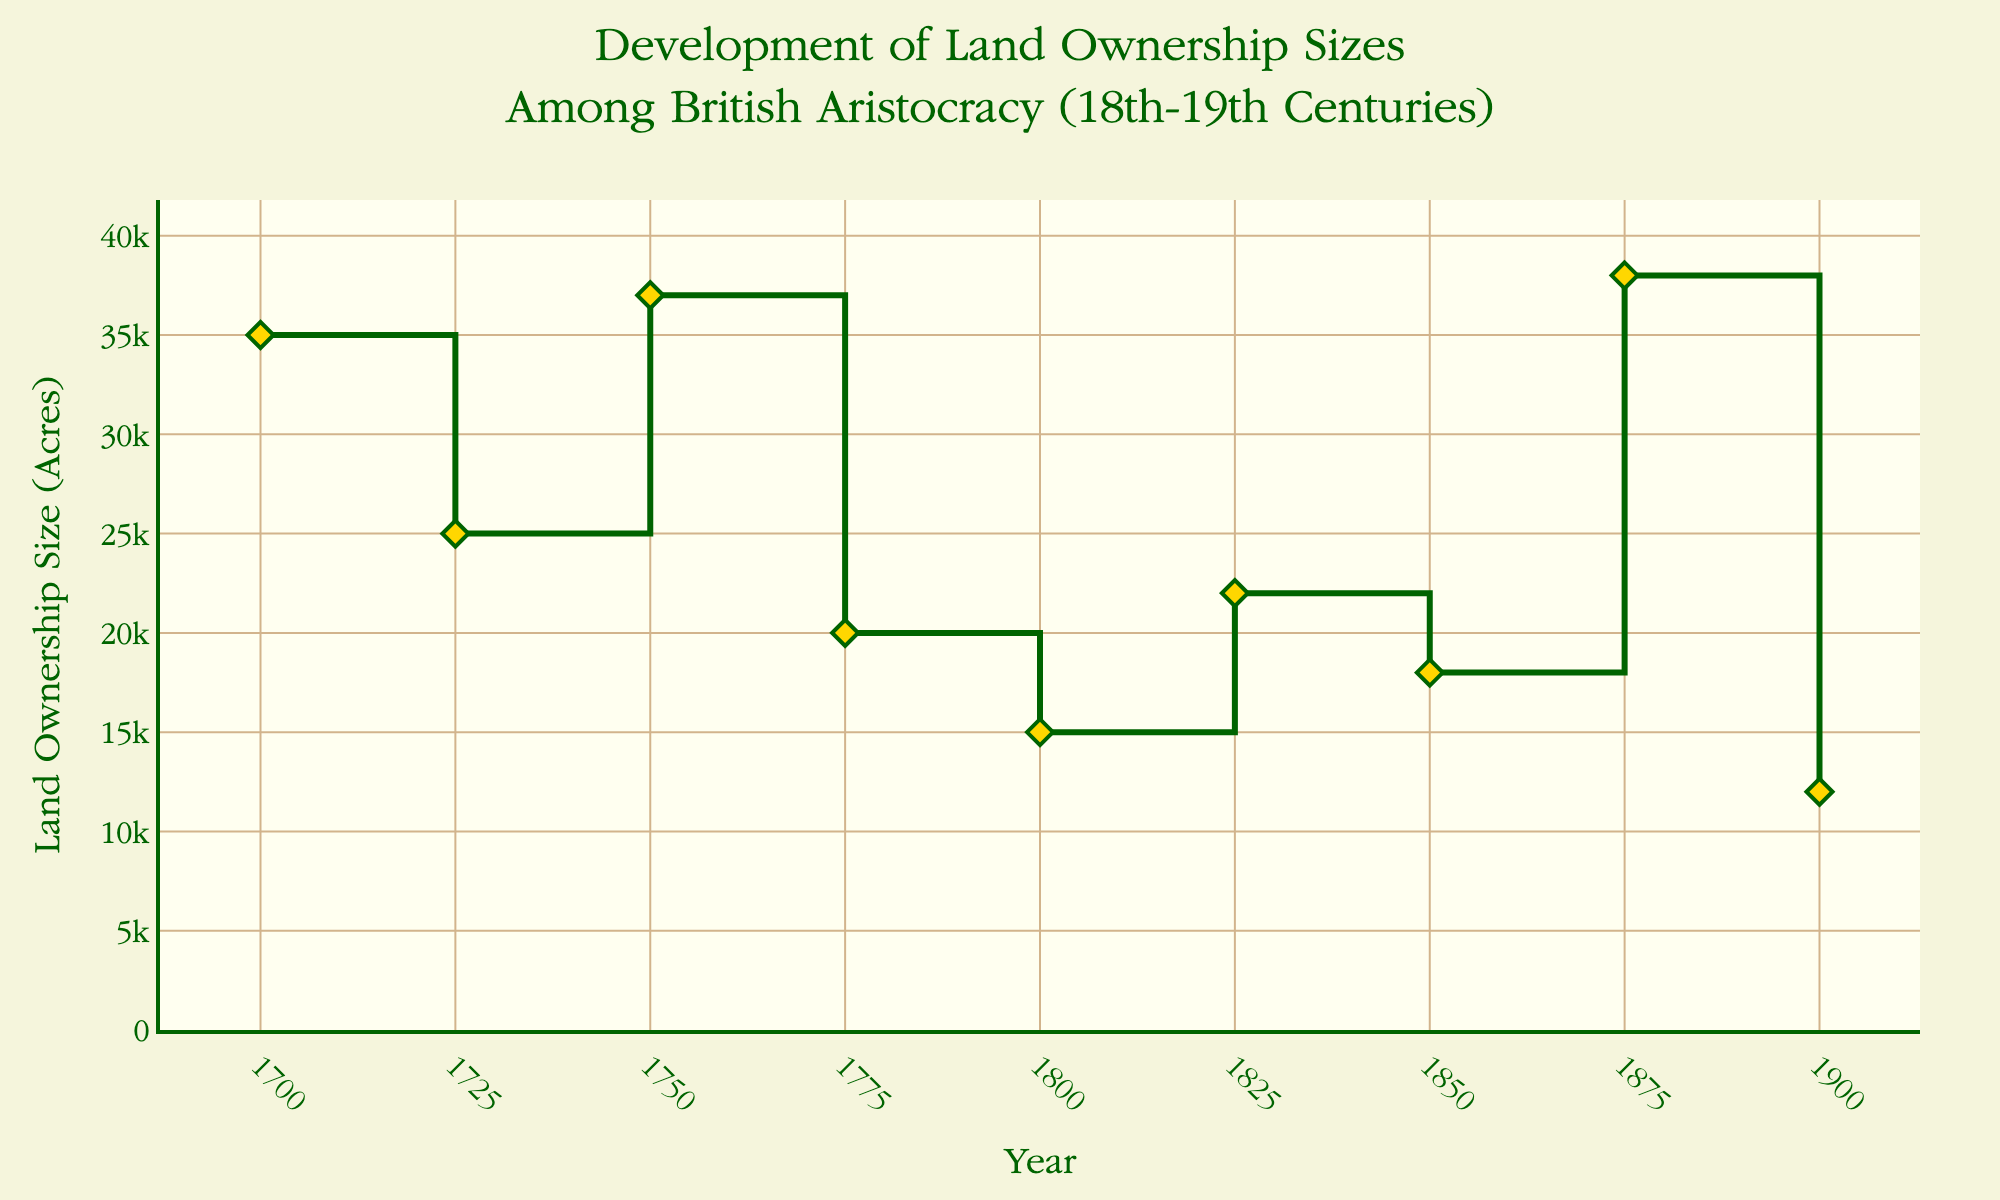How many data points are plotted on the graph? Count the number of markers on the plot, each representing a data point. There are 9 markers on the graph.
Answer: 9 What color are the markers representing the data points? Observe the visual appearance of the markers. The markers are gold in color.
Answer: Gold What is the title of the plot? Read the text at the top of the plot. The title is "Development of Land Ownership Sizes Among British Aristocracy (18th-19th Centuries)."
Answer: Development of Land Ownership Sizes Among British Aristocracy (18th-19th Centuries) Which estate owner had the highest land ownership size and what was the size? Identify the highest point on the y-axis and read the data point's label. The highest land ownership is 38,000 acres owned by Duke of Devonshire in 1875.
Answer: Duke of Devonshire, 38,000 acres Between which years did the estate "Chatsworth House" appear more than once, and what were the ownership sizes? Locate the labels for "Chatsworth House" and note the corresponding years and sizes. Chatsworth House appears in 1700 (35,000 acres) and 1875 (38,000 acres).
Answer: 1700 and 1875; 35,000 acres and 38,000 acres What is the range of years represented in the plot? Look at the x-axis and note the first and last years shown. The range is from 1700 to 1900.
Answer: 1700 to 1900 Which estate had the smallest land ownership size in 1900, and what was the size? Find the data point for the year 1900 and note the estate and size. Talbot Yard had the smallest size, owned by Lord William Montagu with 12,000 acres.
Answer: Talbot Yard, 12,000 acres Between which years did the largest increase in land ownership size occur, and what was the increase? Compare the y-values of consecutive data points and identify the largest difference. The largest increase was between 1825 and 1850, increasing by 3,000 acres (from 22,000 to 25,000 acres).
Answer: 1825 to 1850; 3,000 acres By how many acres did the ownership size of Chatsworth House increase from 1700 to 1875? Subtract the 1700 value from the 1875 value for Chatsworth House. The increase is 38,000 - 35,000 = 3,000 acres.
Answer: 3,000 acres 